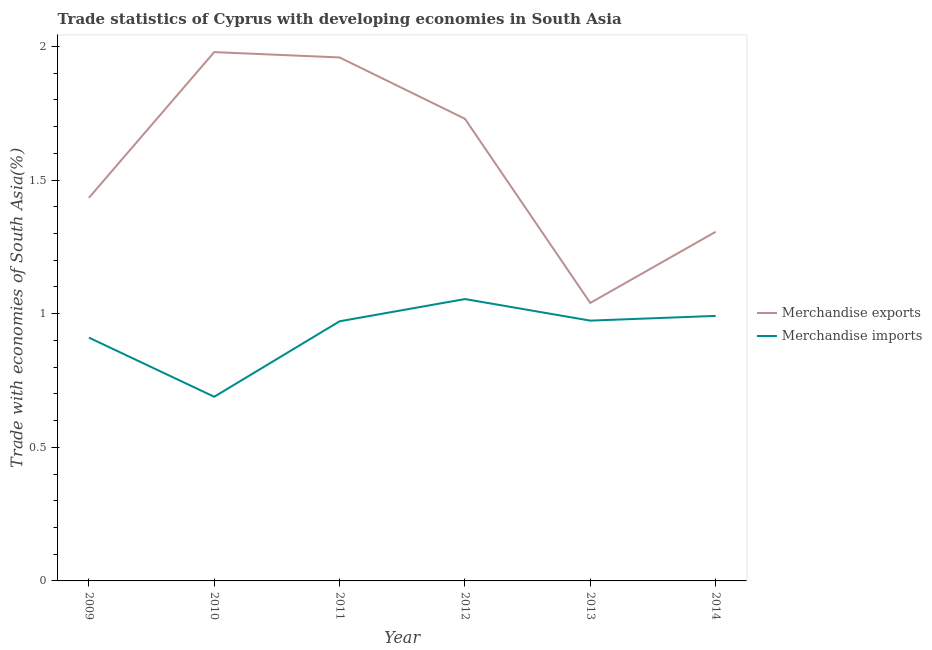How many different coloured lines are there?
Your response must be concise. 2. Does the line corresponding to merchandise exports intersect with the line corresponding to merchandise imports?
Provide a short and direct response. No. Is the number of lines equal to the number of legend labels?
Provide a short and direct response. Yes. What is the merchandise exports in 2010?
Ensure brevity in your answer.  1.98. Across all years, what is the maximum merchandise exports?
Your answer should be compact. 1.98. Across all years, what is the minimum merchandise exports?
Your response must be concise. 1.04. In which year was the merchandise imports maximum?
Your response must be concise. 2012. What is the total merchandise imports in the graph?
Provide a short and direct response. 5.59. What is the difference between the merchandise imports in 2009 and that in 2010?
Give a very brief answer. 0.22. What is the difference between the merchandise imports in 2014 and the merchandise exports in 2011?
Your answer should be compact. -0.97. What is the average merchandise exports per year?
Give a very brief answer. 1.57. In the year 2009, what is the difference between the merchandise imports and merchandise exports?
Your answer should be compact. -0.52. In how many years, is the merchandise exports greater than 1.7 %?
Your answer should be compact. 3. What is the ratio of the merchandise exports in 2010 to that in 2014?
Your answer should be compact. 1.51. Is the merchandise imports in 2009 less than that in 2014?
Your answer should be very brief. Yes. What is the difference between the highest and the second highest merchandise exports?
Make the answer very short. 0.02. What is the difference between the highest and the lowest merchandise imports?
Ensure brevity in your answer.  0.37. In how many years, is the merchandise exports greater than the average merchandise exports taken over all years?
Provide a succinct answer. 3. Is the merchandise exports strictly greater than the merchandise imports over the years?
Provide a short and direct response. Yes. Is the merchandise imports strictly less than the merchandise exports over the years?
Your answer should be very brief. Yes. How many years are there in the graph?
Provide a succinct answer. 6. Does the graph contain any zero values?
Provide a succinct answer. No. Does the graph contain grids?
Give a very brief answer. No. What is the title of the graph?
Provide a short and direct response. Trade statistics of Cyprus with developing economies in South Asia. What is the label or title of the X-axis?
Ensure brevity in your answer.  Year. What is the label or title of the Y-axis?
Give a very brief answer. Trade with economies of South Asia(%). What is the Trade with economies of South Asia(%) in Merchandise exports in 2009?
Your response must be concise. 1.43. What is the Trade with economies of South Asia(%) in Merchandise imports in 2009?
Offer a terse response. 0.91. What is the Trade with economies of South Asia(%) in Merchandise exports in 2010?
Ensure brevity in your answer.  1.98. What is the Trade with economies of South Asia(%) of Merchandise imports in 2010?
Your response must be concise. 0.69. What is the Trade with economies of South Asia(%) in Merchandise exports in 2011?
Your answer should be very brief. 1.96. What is the Trade with economies of South Asia(%) in Merchandise imports in 2011?
Your answer should be very brief. 0.97. What is the Trade with economies of South Asia(%) of Merchandise exports in 2012?
Your answer should be very brief. 1.73. What is the Trade with economies of South Asia(%) in Merchandise imports in 2012?
Your answer should be compact. 1.05. What is the Trade with economies of South Asia(%) of Merchandise exports in 2013?
Your answer should be very brief. 1.04. What is the Trade with economies of South Asia(%) in Merchandise imports in 2013?
Offer a very short reply. 0.97. What is the Trade with economies of South Asia(%) of Merchandise exports in 2014?
Your response must be concise. 1.31. What is the Trade with economies of South Asia(%) in Merchandise imports in 2014?
Keep it short and to the point. 0.99. Across all years, what is the maximum Trade with economies of South Asia(%) of Merchandise exports?
Offer a terse response. 1.98. Across all years, what is the maximum Trade with economies of South Asia(%) in Merchandise imports?
Your answer should be compact. 1.05. Across all years, what is the minimum Trade with economies of South Asia(%) in Merchandise exports?
Make the answer very short. 1.04. Across all years, what is the minimum Trade with economies of South Asia(%) of Merchandise imports?
Your answer should be very brief. 0.69. What is the total Trade with economies of South Asia(%) of Merchandise exports in the graph?
Provide a short and direct response. 9.45. What is the total Trade with economies of South Asia(%) of Merchandise imports in the graph?
Give a very brief answer. 5.59. What is the difference between the Trade with economies of South Asia(%) of Merchandise exports in 2009 and that in 2010?
Provide a short and direct response. -0.55. What is the difference between the Trade with economies of South Asia(%) in Merchandise imports in 2009 and that in 2010?
Your answer should be compact. 0.22. What is the difference between the Trade with economies of South Asia(%) in Merchandise exports in 2009 and that in 2011?
Offer a very short reply. -0.53. What is the difference between the Trade with economies of South Asia(%) of Merchandise imports in 2009 and that in 2011?
Make the answer very short. -0.06. What is the difference between the Trade with economies of South Asia(%) in Merchandise exports in 2009 and that in 2012?
Keep it short and to the point. -0.3. What is the difference between the Trade with economies of South Asia(%) in Merchandise imports in 2009 and that in 2012?
Your answer should be very brief. -0.14. What is the difference between the Trade with economies of South Asia(%) in Merchandise exports in 2009 and that in 2013?
Keep it short and to the point. 0.39. What is the difference between the Trade with economies of South Asia(%) in Merchandise imports in 2009 and that in 2013?
Provide a short and direct response. -0.06. What is the difference between the Trade with economies of South Asia(%) of Merchandise exports in 2009 and that in 2014?
Offer a very short reply. 0.13. What is the difference between the Trade with economies of South Asia(%) in Merchandise imports in 2009 and that in 2014?
Ensure brevity in your answer.  -0.08. What is the difference between the Trade with economies of South Asia(%) of Merchandise imports in 2010 and that in 2011?
Offer a very short reply. -0.28. What is the difference between the Trade with economies of South Asia(%) in Merchandise exports in 2010 and that in 2012?
Your answer should be compact. 0.25. What is the difference between the Trade with economies of South Asia(%) of Merchandise imports in 2010 and that in 2012?
Offer a terse response. -0.37. What is the difference between the Trade with economies of South Asia(%) of Merchandise exports in 2010 and that in 2013?
Offer a very short reply. 0.94. What is the difference between the Trade with economies of South Asia(%) of Merchandise imports in 2010 and that in 2013?
Keep it short and to the point. -0.28. What is the difference between the Trade with economies of South Asia(%) of Merchandise exports in 2010 and that in 2014?
Your answer should be compact. 0.67. What is the difference between the Trade with economies of South Asia(%) of Merchandise imports in 2010 and that in 2014?
Provide a succinct answer. -0.3. What is the difference between the Trade with economies of South Asia(%) of Merchandise exports in 2011 and that in 2012?
Make the answer very short. 0.23. What is the difference between the Trade with economies of South Asia(%) of Merchandise imports in 2011 and that in 2012?
Your response must be concise. -0.08. What is the difference between the Trade with economies of South Asia(%) of Merchandise exports in 2011 and that in 2013?
Offer a very short reply. 0.92. What is the difference between the Trade with economies of South Asia(%) of Merchandise imports in 2011 and that in 2013?
Make the answer very short. -0. What is the difference between the Trade with economies of South Asia(%) of Merchandise exports in 2011 and that in 2014?
Make the answer very short. 0.65. What is the difference between the Trade with economies of South Asia(%) of Merchandise imports in 2011 and that in 2014?
Ensure brevity in your answer.  -0.02. What is the difference between the Trade with economies of South Asia(%) in Merchandise exports in 2012 and that in 2013?
Offer a terse response. 0.69. What is the difference between the Trade with economies of South Asia(%) of Merchandise imports in 2012 and that in 2013?
Your answer should be very brief. 0.08. What is the difference between the Trade with economies of South Asia(%) in Merchandise exports in 2012 and that in 2014?
Give a very brief answer. 0.42. What is the difference between the Trade with economies of South Asia(%) in Merchandise imports in 2012 and that in 2014?
Your answer should be very brief. 0.06. What is the difference between the Trade with economies of South Asia(%) in Merchandise exports in 2013 and that in 2014?
Your response must be concise. -0.27. What is the difference between the Trade with economies of South Asia(%) of Merchandise imports in 2013 and that in 2014?
Ensure brevity in your answer.  -0.02. What is the difference between the Trade with economies of South Asia(%) of Merchandise exports in 2009 and the Trade with economies of South Asia(%) of Merchandise imports in 2010?
Keep it short and to the point. 0.74. What is the difference between the Trade with economies of South Asia(%) in Merchandise exports in 2009 and the Trade with economies of South Asia(%) in Merchandise imports in 2011?
Your answer should be compact. 0.46. What is the difference between the Trade with economies of South Asia(%) in Merchandise exports in 2009 and the Trade with economies of South Asia(%) in Merchandise imports in 2012?
Provide a short and direct response. 0.38. What is the difference between the Trade with economies of South Asia(%) of Merchandise exports in 2009 and the Trade with economies of South Asia(%) of Merchandise imports in 2013?
Offer a very short reply. 0.46. What is the difference between the Trade with economies of South Asia(%) of Merchandise exports in 2009 and the Trade with economies of South Asia(%) of Merchandise imports in 2014?
Your response must be concise. 0.44. What is the difference between the Trade with economies of South Asia(%) in Merchandise exports in 2010 and the Trade with economies of South Asia(%) in Merchandise imports in 2011?
Your response must be concise. 1.01. What is the difference between the Trade with economies of South Asia(%) in Merchandise exports in 2010 and the Trade with economies of South Asia(%) in Merchandise imports in 2012?
Your answer should be compact. 0.92. What is the difference between the Trade with economies of South Asia(%) in Merchandise exports in 2010 and the Trade with economies of South Asia(%) in Merchandise imports in 2014?
Your response must be concise. 0.99. What is the difference between the Trade with economies of South Asia(%) of Merchandise exports in 2011 and the Trade with economies of South Asia(%) of Merchandise imports in 2012?
Provide a short and direct response. 0.9. What is the difference between the Trade with economies of South Asia(%) of Merchandise exports in 2011 and the Trade with economies of South Asia(%) of Merchandise imports in 2013?
Offer a terse response. 0.98. What is the difference between the Trade with economies of South Asia(%) in Merchandise exports in 2011 and the Trade with economies of South Asia(%) in Merchandise imports in 2014?
Your response must be concise. 0.97. What is the difference between the Trade with economies of South Asia(%) in Merchandise exports in 2012 and the Trade with economies of South Asia(%) in Merchandise imports in 2013?
Provide a short and direct response. 0.76. What is the difference between the Trade with economies of South Asia(%) in Merchandise exports in 2012 and the Trade with economies of South Asia(%) in Merchandise imports in 2014?
Make the answer very short. 0.74. What is the difference between the Trade with economies of South Asia(%) of Merchandise exports in 2013 and the Trade with economies of South Asia(%) of Merchandise imports in 2014?
Your answer should be compact. 0.05. What is the average Trade with economies of South Asia(%) of Merchandise exports per year?
Make the answer very short. 1.57. What is the average Trade with economies of South Asia(%) of Merchandise imports per year?
Offer a terse response. 0.93. In the year 2009, what is the difference between the Trade with economies of South Asia(%) of Merchandise exports and Trade with economies of South Asia(%) of Merchandise imports?
Provide a short and direct response. 0.52. In the year 2010, what is the difference between the Trade with economies of South Asia(%) in Merchandise exports and Trade with economies of South Asia(%) in Merchandise imports?
Offer a very short reply. 1.29. In the year 2011, what is the difference between the Trade with economies of South Asia(%) of Merchandise exports and Trade with economies of South Asia(%) of Merchandise imports?
Make the answer very short. 0.99. In the year 2012, what is the difference between the Trade with economies of South Asia(%) of Merchandise exports and Trade with economies of South Asia(%) of Merchandise imports?
Keep it short and to the point. 0.67. In the year 2013, what is the difference between the Trade with economies of South Asia(%) in Merchandise exports and Trade with economies of South Asia(%) in Merchandise imports?
Offer a very short reply. 0.07. In the year 2014, what is the difference between the Trade with economies of South Asia(%) of Merchandise exports and Trade with economies of South Asia(%) of Merchandise imports?
Give a very brief answer. 0.31. What is the ratio of the Trade with economies of South Asia(%) in Merchandise exports in 2009 to that in 2010?
Give a very brief answer. 0.72. What is the ratio of the Trade with economies of South Asia(%) of Merchandise imports in 2009 to that in 2010?
Provide a short and direct response. 1.32. What is the ratio of the Trade with economies of South Asia(%) of Merchandise exports in 2009 to that in 2011?
Provide a succinct answer. 0.73. What is the ratio of the Trade with economies of South Asia(%) in Merchandise imports in 2009 to that in 2011?
Give a very brief answer. 0.94. What is the ratio of the Trade with economies of South Asia(%) of Merchandise exports in 2009 to that in 2012?
Provide a short and direct response. 0.83. What is the ratio of the Trade with economies of South Asia(%) in Merchandise imports in 2009 to that in 2012?
Provide a short and direct response. 0.86. What is the ratio of the Trade with economies of South Asia(%) of Merchandise exports in 2009 to that in 2013?
Your answer should be compact. 1.38. What is the ratio of the Trade with economies of South Asia(%) of Merchandise imports in 2009 to that in 2013?
Keep it short and to the point. 0.93. What is the ratio of the Trade with economies of South Asia(%) in Merchandise exports in 2009 to that in 2014?
Give a very brief answer. 1.1. What is the ratio of the Trade with economies of South Asia(%) in Merchandise imports in 2009 to that in 2014?
Your response must be concise. 0.92. What is the ratio of the Trade with economies of South Asia(%) in Merchandise exports in 2010 to that in 2011?
Give a very brief answer. 1.01. What is the ratio of the Trade with economies of South Asia(%) of Merchandise imports in 2010 to that in 2011?
Keep it short and to the point. 0.71. What is the ratio of the Trade with economies of South Asia(%) in Merchandise exports in 2010 to that in 2012?
Your answer should be compact. 1.14. What is the ratio of the Trade with economies of South Asia(%) in Merchandise imports in 2010 to that in 2012?
Offer a very short reply. 0.65. What is the ratio of the Trade with economies of South Asia(%) in Merchandise exports in 2010 to that in 2013?
Provide a short and direct response. 1.9. What is the ratio of the Trade with economies of South Asia(%) in Merchandise imports in 2010 to that in 2013?
Your answer should be very brief. 0.71. What is the ratio of the Trade with economies of South Asia(%) in Merchandise exports in 2010 to that in 2014?
Keep it short and to the point. 1.51. What is the ratio of the Trade with economies of South Asia(%) of Merchandise imports in 2010 to that in 2014?
Provide a short and direct response. 0.69. What is the ratio of the Trade with economies of South Asia(%) of Merchandise exports in 2011 to that in 2012?
Provide a short and direct response. 1.13. What is the ratio of the Trade with economies of South Asia(%) in Merchandise imports in 2011 to that in 2012?
Provide a short and direct response. 0.92. What is the ratio of the Trade with economies of South Asia(%) in Merchandise exports in 2011 to that in 2013?
Your answer should be compact. 1.88. What is the ratio of the Trade with economies of South Asia(%) in Merchandise imports in 2011 to that in 2013?
Your answer should be compact. 1. What is the ratio of the Trade with economies of South Asia(%) in Merchandise exports in 2011 to that in 2014?
Provide a succinct answer. 1.5. What is the ratio of the Trade with economies of South Asia(%) in Merchandise imports in 2011 to that in 2014?
Make the answer very short. 0.98. What is the ratio of the Trade with economies of South Asia(%) of Merchandise exports in 2012 to that in 2013?
Ensure brevity in your answer.  1.66. What is the ratio of the Trade with economies of South Asia(%) in Merchandise imports in 2012 to that in 2013?
Your answer should be very brief. 1.08. What is the ratio of the Trade with economies of South Asia(%) in Merchandise exports in 2012 to that in 2014?
Offer a terse response. 1.32. What is the ratio of the Trade with economies of South Asia(%) in Merchandise imports in 2012 to that in 2014?
Provide a short and direct response. 1.06. What is the ratio of the Trade with economies of South Asia(%) in Merchandise exports in 2013 to that in 2014?
Your response must be concise. 0.8. What is the ratio of the Trade with economies of South Asia(%) of Merchandise imports in 2013 to that in 2014?
Offer a terse response. 0.98. What is the difference between the highest and the second highest Trade with economies of South Asia(%) of Merchandise exports?
Offer a terse response. 0.02. What is the difference between the highest and the second highest Trade with economies of South Asia(%) in Merchandise imports?
Provide a succinct answer. 0.06. What is the difference between the highest and the lowest Trade with economies of South Asia(%) of Merchandise exports?
Provide a succinct answer. 0.94. What is the difference between the highest and the lowest Trade with economies of South Asia(%) in Merchandise imports?
Give a very brief answer. 0.37. 